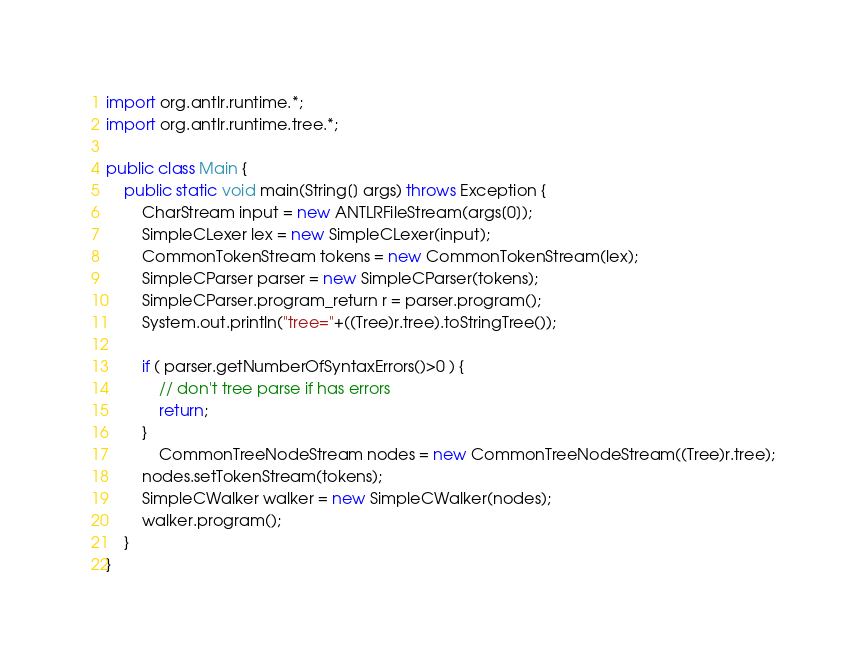<code> <loc_0><loc_0><loc_500><loc_500><_Java_>import org.antlr.runtime.*;
import org.antlr.runtime.tree.*;

public class Main {
	public static void main(String[] args) throws Exception {
		CharStream input = new ANTLRFileStream(args[0]);
		SimpleCLexer lex = new SimpleCLexer(input);
		CommonTokenStream tokens = new CommonTokenStream(lex);
		SimpleCParser parser = new SimpleCParser(tokens);
		SimpleCParser.program_return r = parser.program();
		System.out.println("tree="+((Tree)r.tree).toStringTree());

		if ( parser.getNumberOfSyntaxErrors()>0 ) {
			// don't tree parse if has errors
			return;
		}
        	CommonTreeNodeStream nodes = new CommonTreeNodeStream((Tree)r.tree);
		nodes.setTokenStream(tokens);
		SimpleCWalker walker = new SimpleCWalker(nodes);
		walker.program();
	}
}
</code> 